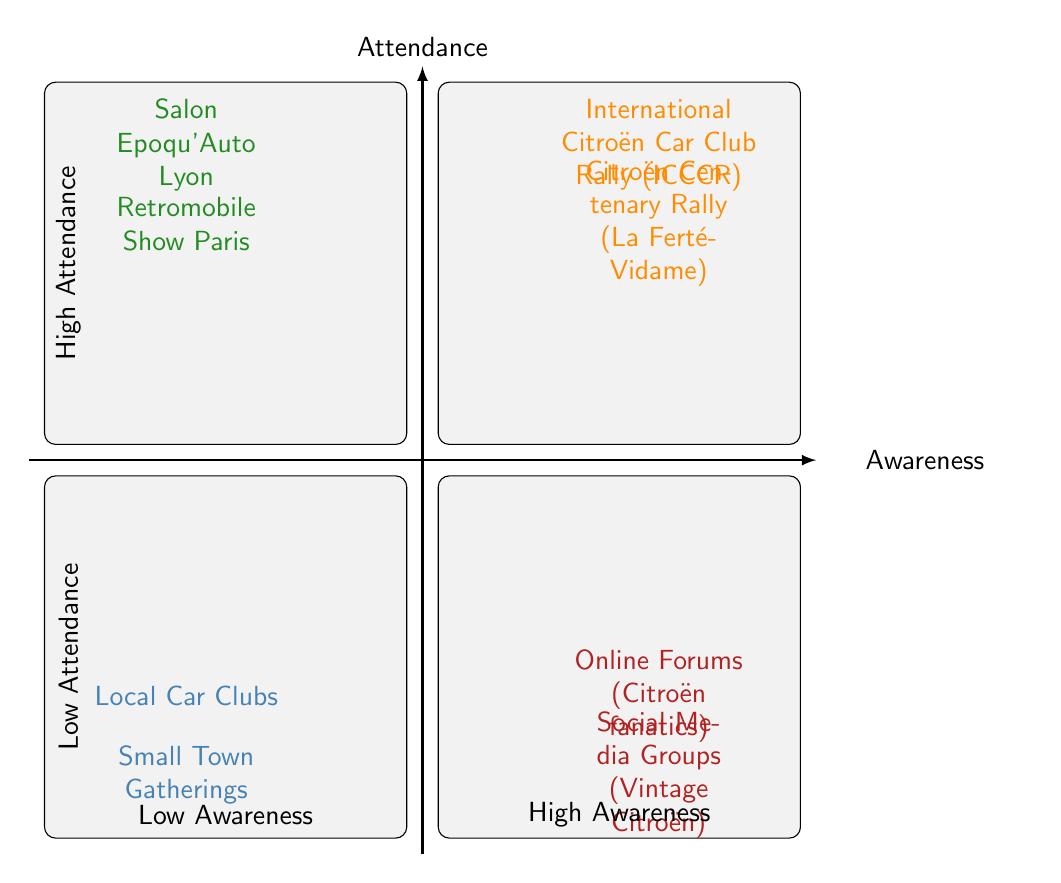What events have low attendance and low awareness? This quadrant contains the events that are marked low in both attendance and awareness. Looking into the quadrant labeled "Low Attendance, Low Awareness," the events listed are "Local Car Clubs" and "Small Town Gatherings."
Answer: Local Car Clubs, Small Town Gatherings Which event has high awareness but low attendance? In the upper right quadrant of the diagram, indicating high awareness but low attendance, the events specified are those related to online platforms, namely "Online Forums (Citroën fanatics)" and "Social Media Groups (Vintage Citroën)."
Answer: Online Forums (Citroën fanatics), Social Media Groups (Vintage Citroën) What is the common characteristic of events in the High Attendance, High Awareness quadrant? The events in this quadrant are noted for having both significant attendance and a strong awareness within the community. The specific events mentioned are "Citroën Centenary Rally (La Ferté-Vidame)" and "International Citroën Car Club Rally (ICCCR)."
Answer: Citroën Centenary Rally (La Ferté-Vidame), International Citroën Car Club Rally (ICCCR) How many events are categorized as having low awareness? To find the count of events with low awareness, we look at both left quadrants of the diagram titled "Low Awareness." The events within are "Local Car Clubs," "Small Town Gatherings," "Online Forums (Citroën fanatics)," and "Social Media Groups (Vintage Citroën)." Hence, when summed, we have four events overall.
Answer: 4 Which quadrant contains no events? By inspecting the diagram, only the quadrants "High Attendance, Low Awareness" and "Low Attendance, High Awareness" contain specified events. Therefore, focusing on the areas that are empty reveals that the "Low Attendance, Low Awareness" quadrant has the noted events without omission.
Answer: None What is a characteristic of events found in the Low Attendance quadrant? Investigating the lower sections of the chart identified as low attendance results in two separate categories: "Low Attendance, Low Awareness" and "High Attendance, Low Awareness." Notably, events in the low attendance category do not attract significant crowds.
Answer: They do not attract significant crowds Which events are specified with high attendance? In the diagram, events that fall into the high attendance category are found in the top quadrants. Specifically, these include "Retromobile Show Paris," "Salon Epoqu’Auto Lyon," "Citroën Centenary Rally (La Ferté-Vidame)," and "International Citroën Car Club Rally (ICCCR)."
Answer: Retromobile Show Paris, Salon Epoqu’Auto Lyon, Citroën Centenary Rally (La Ferté-Vidame), International Citroën Car Club Rally (ICCCR) What does the horizontal axis represent in this diagram? The horizontal axis of the diagram indicates the level of awareness for the events. It describes awareness going from low on the left side to high on the right side, establishing a clear distinction in how well-known the events are.
Answer: Awareness 